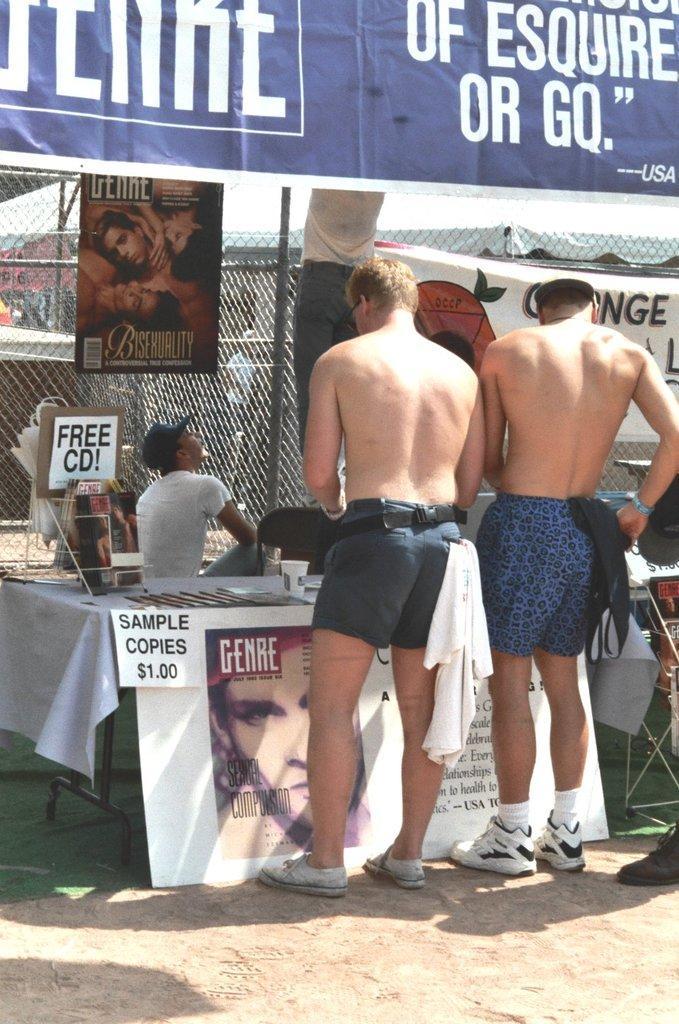Please provide a concise description of this image. In this image there are people standing on a land, in the background there is a table, on that table there are few and there is a banner, on that banner there is some text, at the top there is a roof and a banner on that banner there is some text, in the background there is fencing and there are posters. 